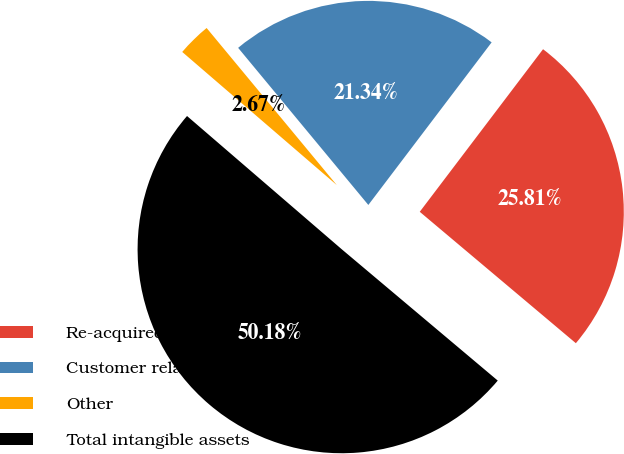<chart> <loc_0><loc_0><loc_500><loc_500><pie_chart><fcel>Re-acquired licensed<fcel>Customer relationships<fcel>Other<fcel>Total intangible assets<nl><fcel>25.81%<fcel>21.34%<fcel>2.67%<fcel>50.18%<nl></chart> 